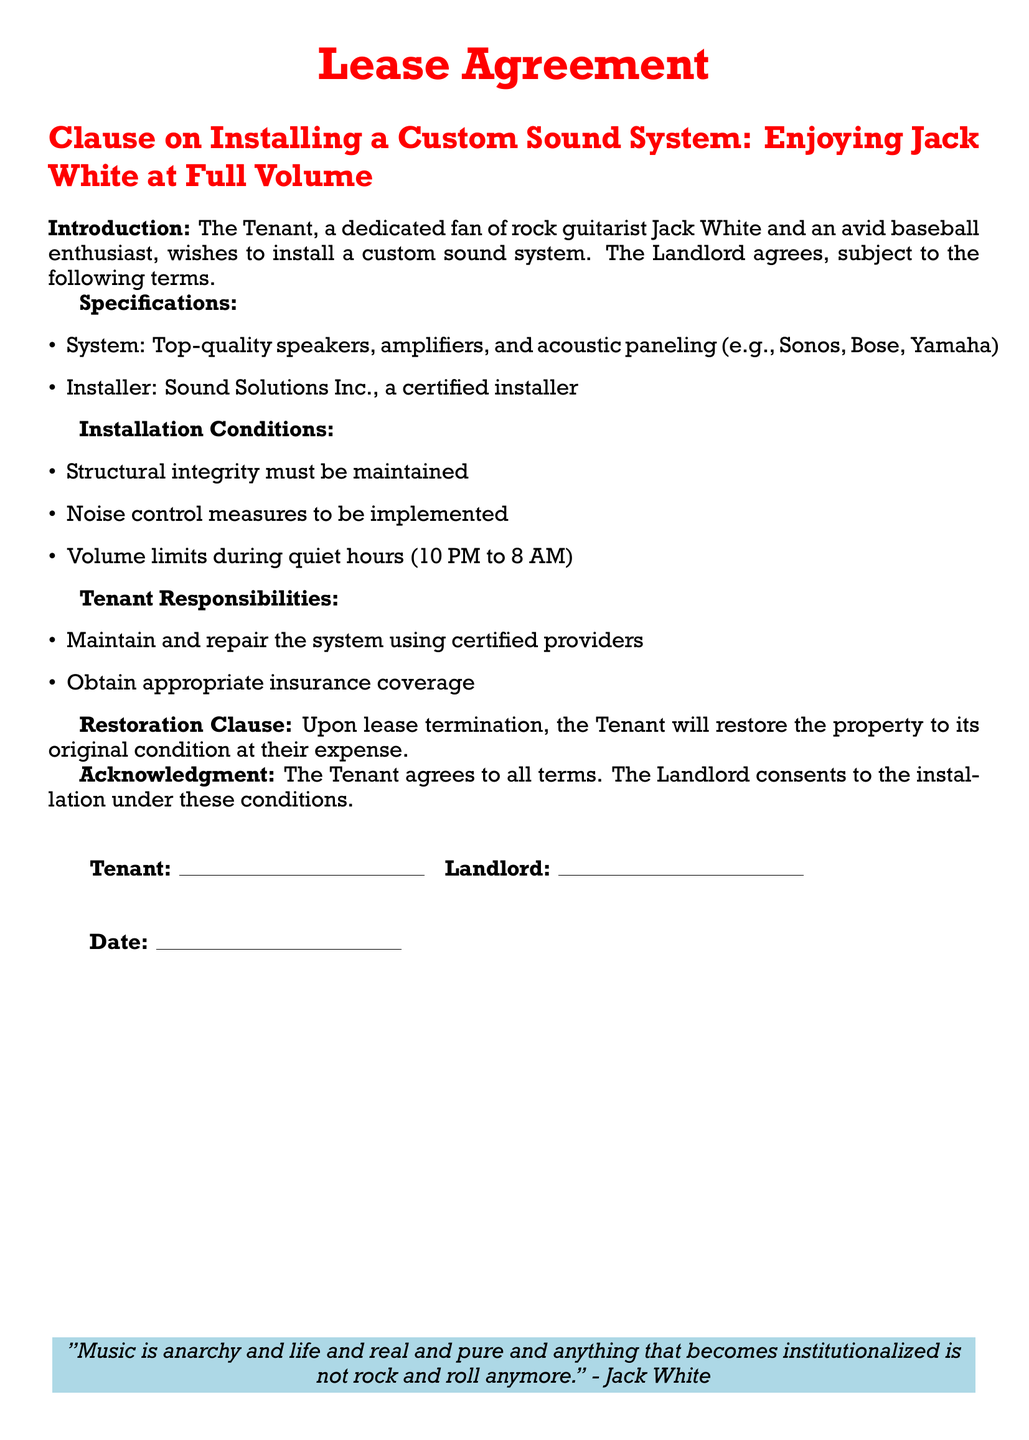What is the purpose of the clause? The purpose of the clause is to allow the Tenant to install a custom sound system while outlining conditions.
Answer: Allowing installation under conditions What are the quiet hours mentioned? The document specifies the hours during which noise limits apply, which are mentioned explicitly.
Answer: 10 PM to 8 AM Who is the certified installer? The document identifies a specific company responsible for the installation of the sound system.
Answer: Sound Solutions Inc What must the Tenant maintain and repair? The clause mentions what the Tenant is responsible for regarding the sound system.
Answer: The system What happens to the property upon lease termination? The Restoration Clause specifies the requirement of property condition after the lease ends.
Answer: Restore to original condition What type of insurance does the Tenant need? The document states a specific requirement regarding insurance without details but implies that coverage is necessary.
Answer: Appropriate insurance coverage What is the color used for the title format? The document references a specific color for titles to align with a theme.
Answer: Jack White What kind of sound system can be installed? The specifications outline the qualities of the sound system that can be installed by referencing product types.
Answer: Top-quality speakers, amplifiers, and acoustic paneling 